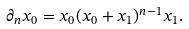<formula> <loc_0><loc_0><loc_500><loc_500>\partial _ { n } x _ { 0 } = x _ { 0 } ( x _ { 0 } + x _ { 1 } ) ^ { n - 1 } x _ { 1 } .</formula> 